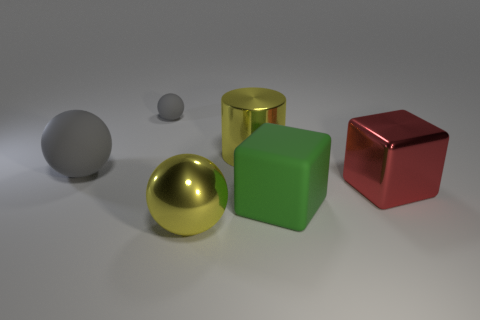What color is the metallic thing that is on the left side of the red block and behind the green rubber block?
Your answer should be compact. Yellow. Is the number of tiny yellow matte spheres less than the number of large red metal blocks?
Make the answer very short. Yes. Is the color of the cylinder the same as the large sphere in front of the big green rubber cube?
Your answer should be compact. Yes. Is the number of big metallic cubes behind the small matte thing the same as the number of yellow metal balls that are behind the metal cylinder?
Your answer should be very brief. Yes. How many other tiny gray things have the same shape as the small gray matte object?
Keep it short and to the point. 0. Is there a red cube?
Provide a succinct answer. Yes. Is the large red thing made of the same material as the large yellow ball that is in front of the green thing?
Give a very brief answer. Yes. What material is the yellow cylinder that is the same size as the red metal object?
Your response must be concise. Metal. Are there any tiny red things made of the same material as the green object?
Offer a very short reply. No. Are there any metal cylinders that are in front of the large object in front of the big matte object right of the tiny thing?
Give a very brief answer. No. 